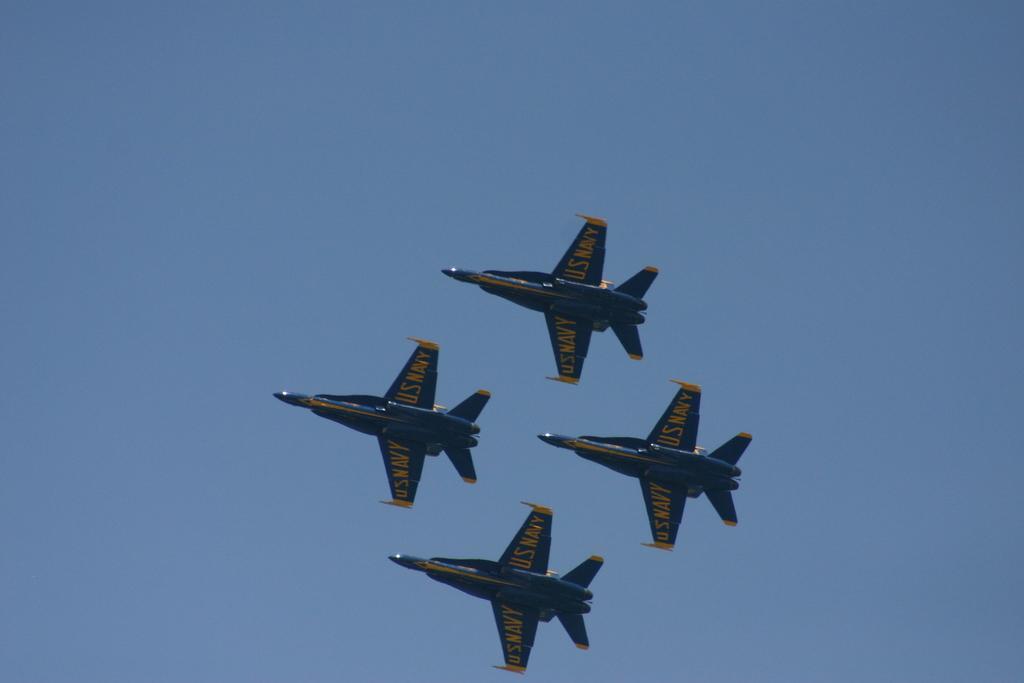In one or two sentences, can you explain what this image depicts? In this image we can see four aircrafts flying in the sky, also we can see some text on them. 